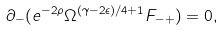<formula> <loc_0><loc_0><loc_500><loc_500>\partial _ { - } ( e ^ { - 2 \rho } \Omega ^ { ( \gamma - 2 \epsilon ) / 4 + 1 } F _ { - + } ) = 0 ,</formula> 